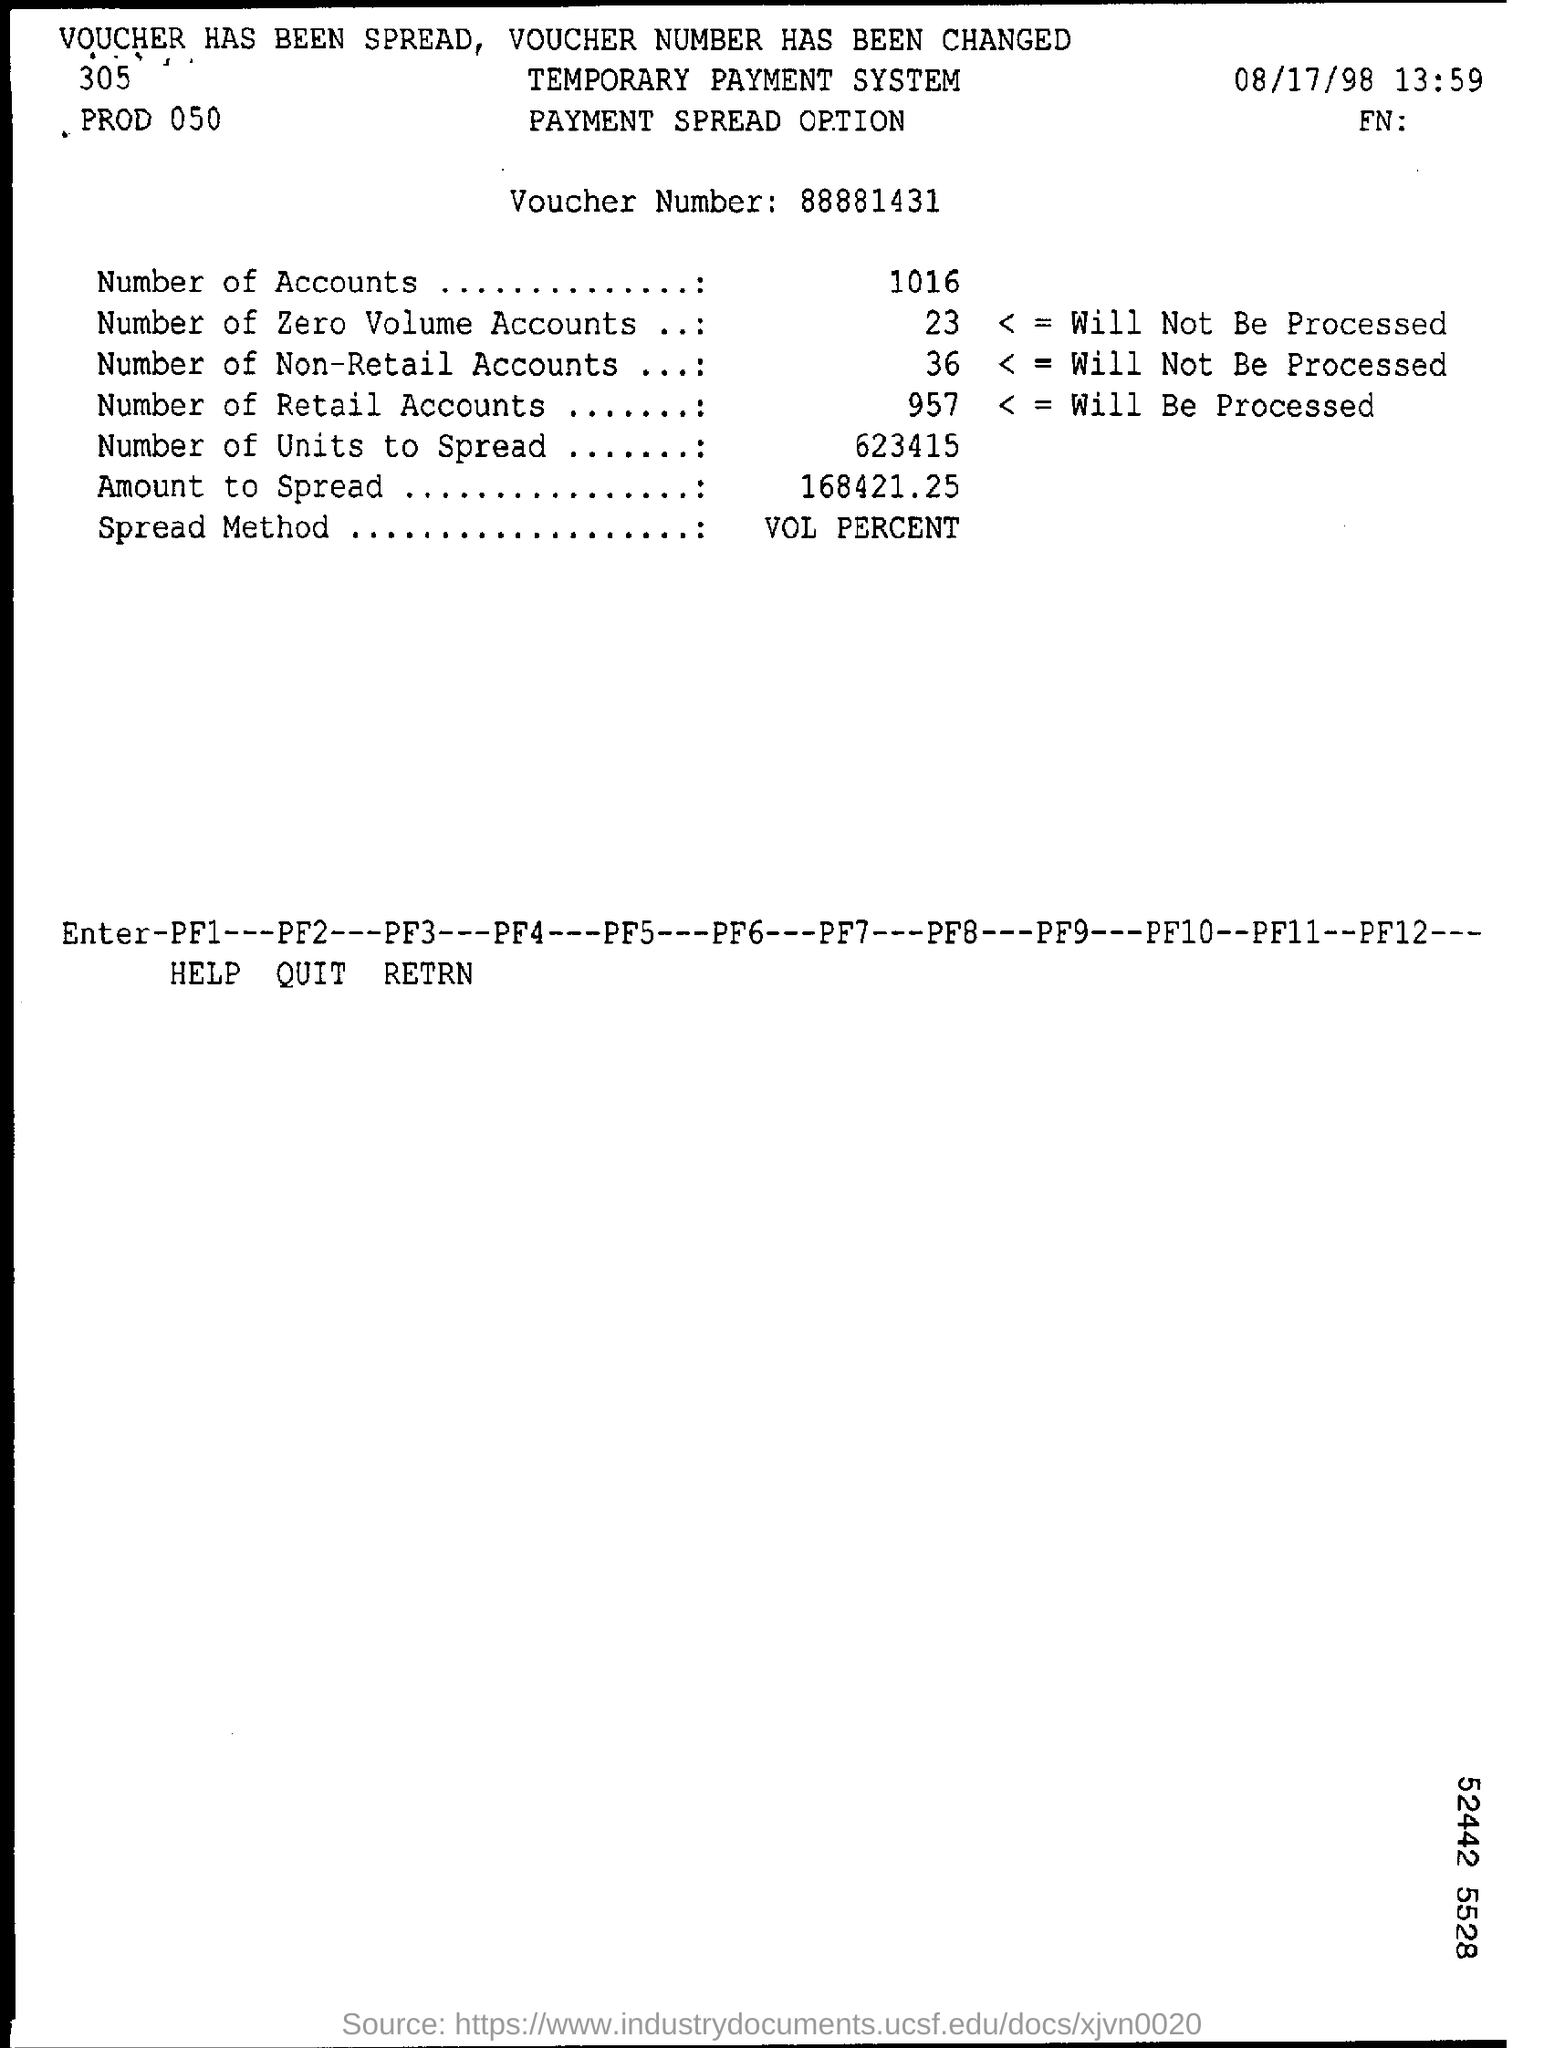List a handful of essential elements in this visual. What is the spread method? It is a method used to calculate the value at risk (VaR) of a portfolio, where the VaR is the maximum loss that a portfolio is likely to experience over a given time horizon with a given confidence level. The VaR is calculated by taking the standard deviation of the portfolio's returns and multiplying it by the confidence level and the square root of the time horizon. To calculate the VaR of a portfolio, we can use the spread method. There are a total of 1016 accounts mentioned. The date mentioned is August 17, 1998. I would like to know the voucher number, specifically 88881431... . 